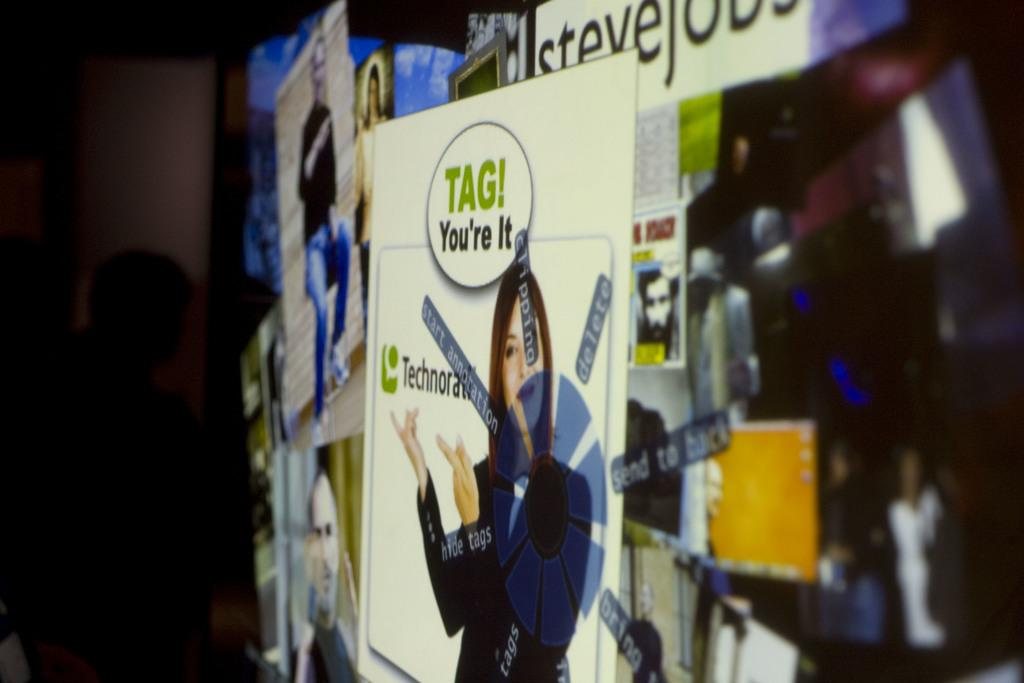<image>
Offer a succinct explanation of the picture presented. An ad has the phrase tag, you're it above a woman. 